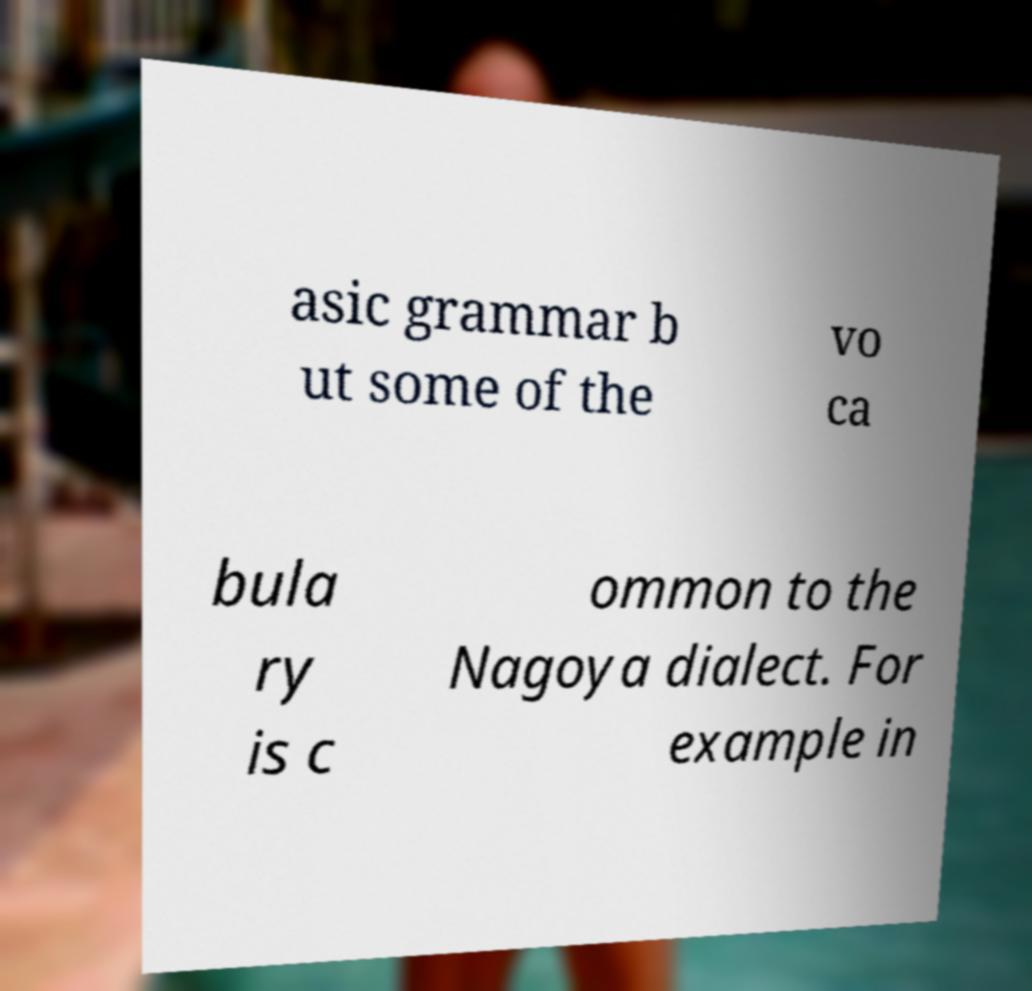Could you assist in decoding the text presented in this image and type it out clearly? asic grammar b ut some of the vo ca bula ry is c ommon to the Nagoya dialect. For example in 